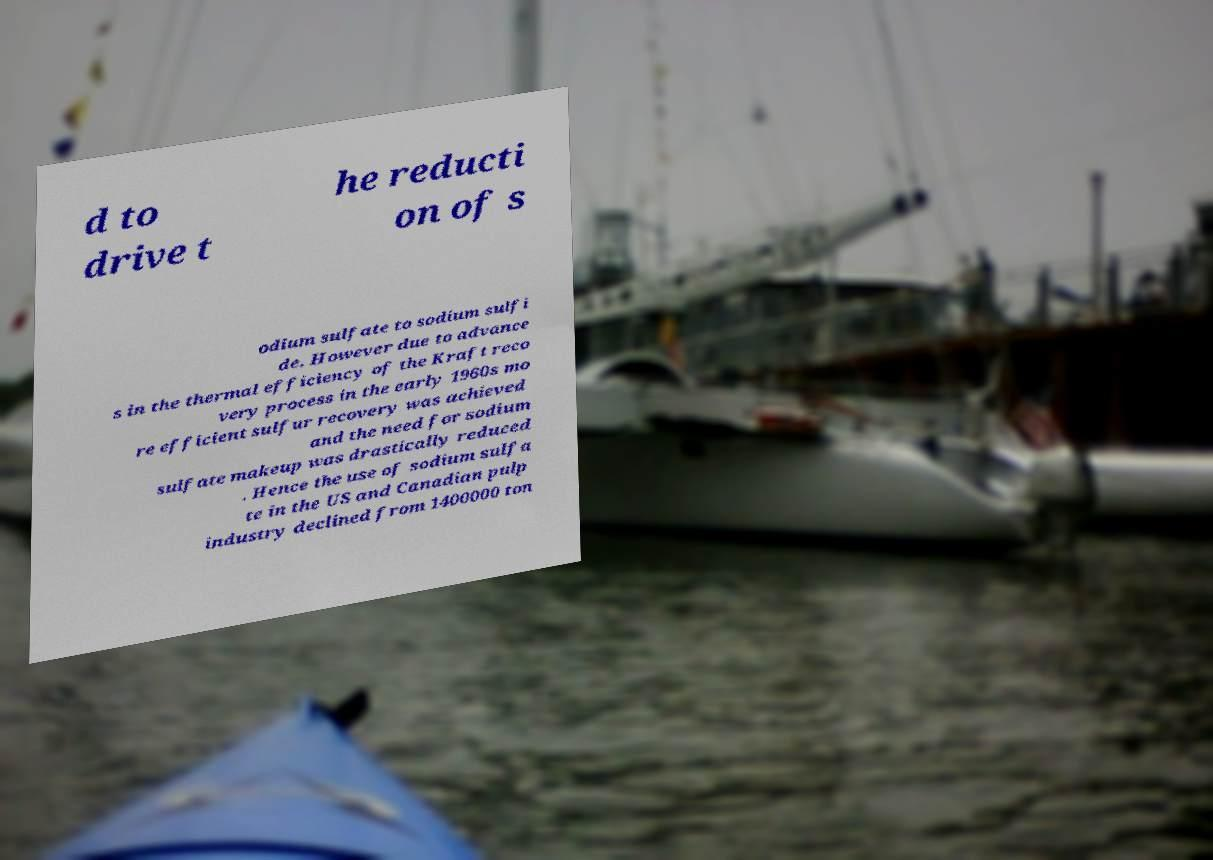Could you assist in decoding the text presented in this image and type it out clearly? d to drive t he reducti on of s odium sulfate to sodium sulfi de. However due to advance s in the thermal efficiency of the Kraft reco very process in the early 1960s mo re efficient sulfur recovery was achieved and the need for sodium sulfate makeup was drastically reduced . Hence the use of sodium sulfa te in the US and Canadian pulp industry declined from 1400000 ton 